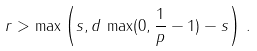<formula> <loc_0><loc_0><loc_500><loc_500>r > \max \left ( s , d \, \max ( 0 , \frac { 1 } { p } - 1 ) - s \right ) \, .</formula> 